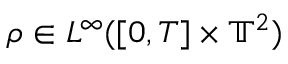<formula> <loc_0><loc_0><loc_500><loc_500>\rho \in L ^ { \infty } ( [ 0 , T ] \times \mathbb { T } ^ { 2 } )</formula> 